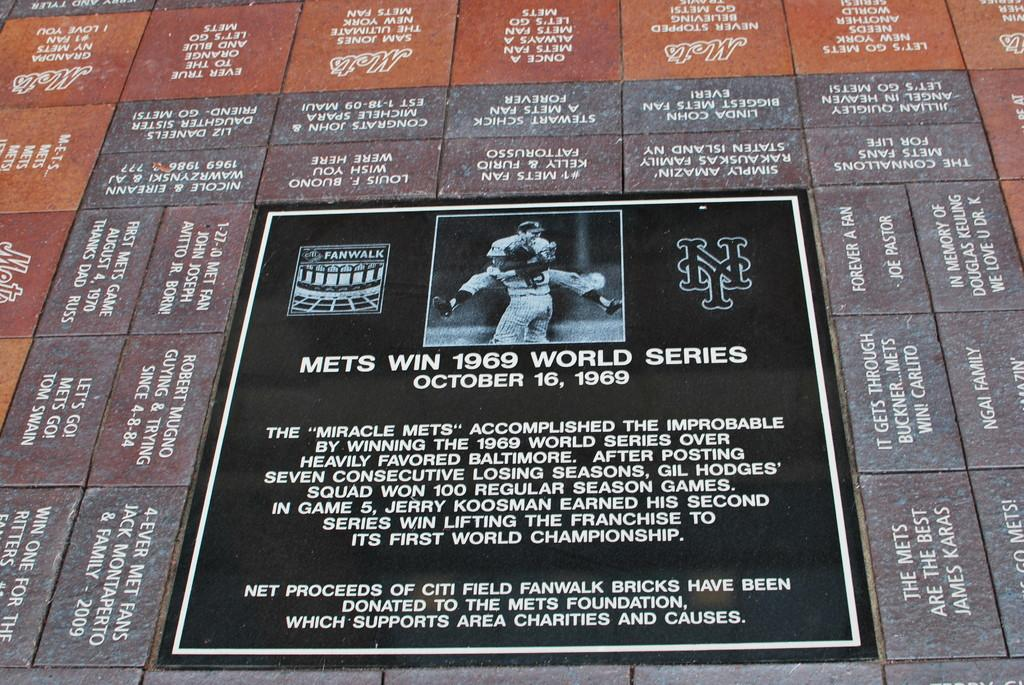What is the main object in the image? There is a board in the image. What is depicted on the board? The board has an image of two persons. What is the color of the text on the board? The board has white color texts. Where is the board located? The board is on a wall. What else can be seen on the wall? The wall has name boards. What hobbies do the two persons depicted on the board enjoy? The image of the two persons does not provide information about their hobbies. Is there any wire visible in the image? There is no wire visible in the image. 